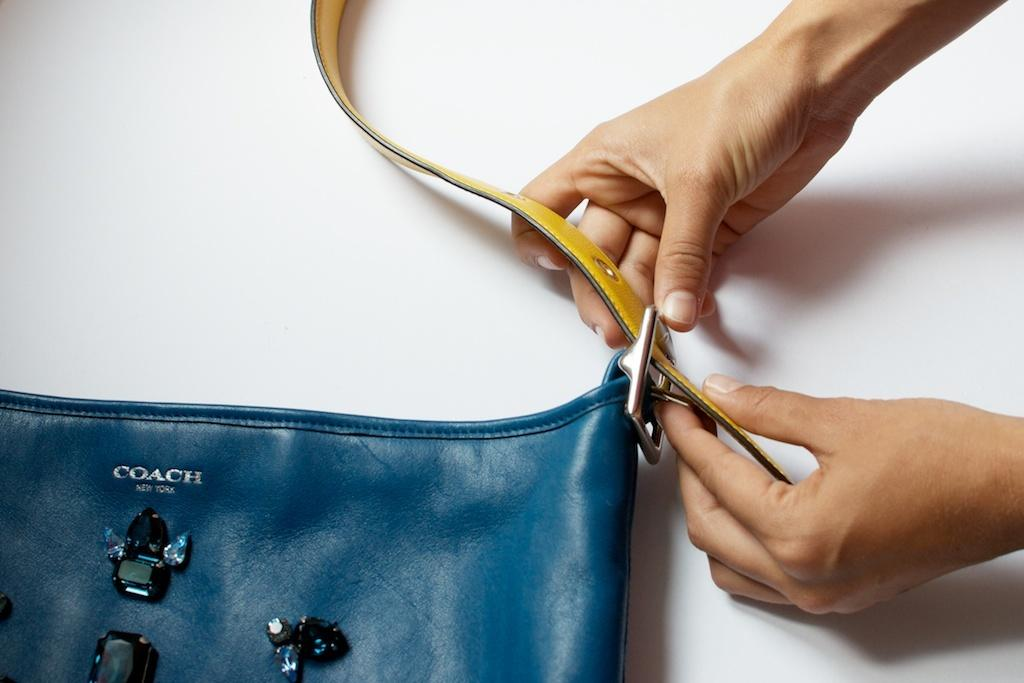Who or what is the main subject in the image? There is a person in the image. What is the person holding in the image? The person is holding a belt. What can be seen in front of the person? There is a blue bag in front of the person. What color is the background behind the person and the bag? The background of the bag and person is white. How many houses are visible in the image? There are no houses visible in the image; it features a person holding a belt and a blue bag in front of a white background. 